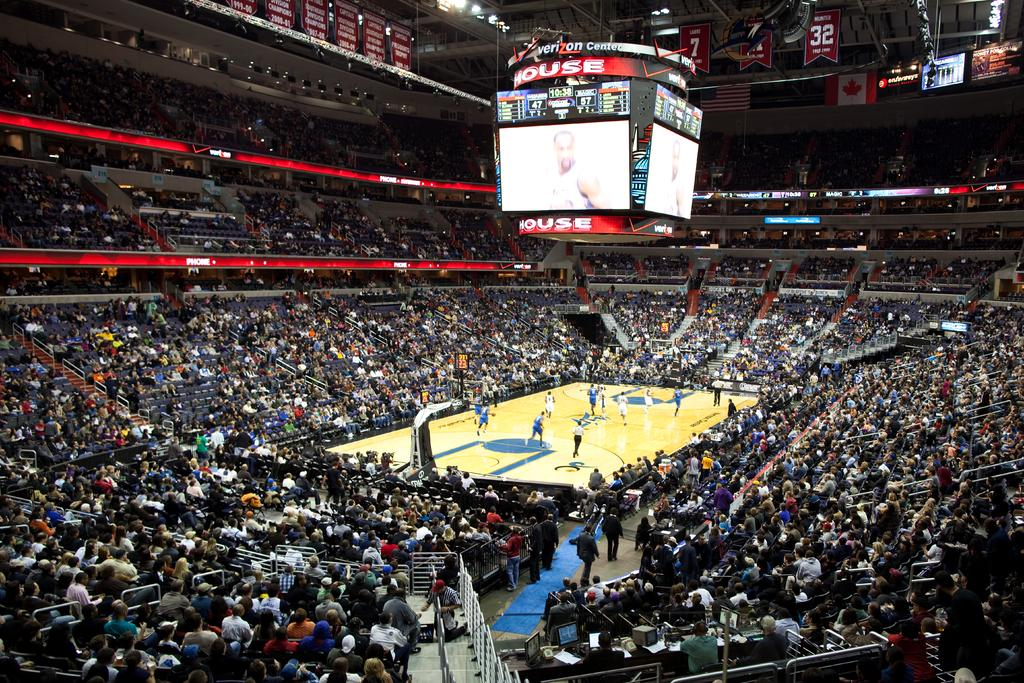Provide a one-sentence caption for the provided image. A full stadium at the Verizon Center watching a basketball game. 